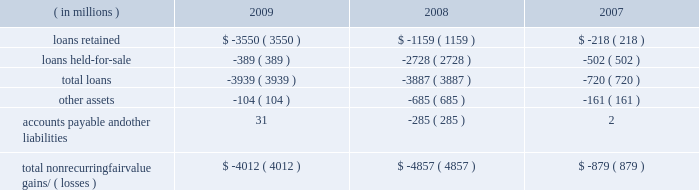Notes to consolidated financial statements jpmorgan chase & co./2009 annual report 168 nonrecurring fair value changes the table presents the total change in value of financial instruments for which a fair value adjustment has been included in the consolidated statements of income for the years ended december 31 , 2009 , 2008 and 2007 , related to financial instru- ments held at these dates .
Year ended december 31 .
Accounts payable and other liabilities 31 ( 285 ) 2 total nonrecurring fair value gains/ ( losses ) $ ( 4012 ) $ ( 4857 ) $ ( 879 ) in the above table , loans predominantly include : ( 1 ) write-downs of delinquent mortgage and home equity loans where impairment is based on the fair value of the underlying collateral ; and ( 2 ) the change in fair value for leveraged lending loans carried on the consolidated balance sheets at the lower of cost or fair value .
Accounts payable and other liabilities predominantly include the change in fair value for unfunded lending-related commitments within the leveraged lending portfolio .
Level 3 analysis level 3 assets ( including assets measured at fair value on a nonre- curring basis ) were 6% ( 6 % ) of total firm assets at both december 31 , 2009 and 2008 .
Level 3 assets were $ 130.4 billion at december 31 , 2009 , reflecting a decrease of $ 7.3 billion in 2009 , due to the following : 2022 a net decrease of $ 6.3 billion in gross derivative receivables , predominantly driven by the tightening of credit spreads .
Offset- ting a portion of the decrease were net transfers into level 3 dur- ing the year , most notably a transfer into level 3 of $ 41.3 billion of structured credit derivative receivables , and a transfer out of level 3 of $ 17.7 billion of single-name cds on abs .
The fair value of the receivables transferred into level 3 during the year was $ 22.1 billion at december 31 , 2009 .
The fair value of struc- tured credit derivative payables with a similar underlying risk profile to the previously noted receivables , that are also classified in level 3 , was $ 12.5 billion at december 31 , 2009 .
These de- rivatives payables offset the receivables , as they are modeled and valued the same way with the same parameters and inputs as the assets .
2022 a net decrease of $ 3.5 billion in loans , predominantly driven by sales of leveraged loans and transfers of similar loans to level 2 , due to increased price transparency for such assets .
Leveraged loans are typically classified as held-for-sale and measured at the lower of cost or fair value and , therefore , included in the nonre- curring fair value assets .
2022 a net decrease of $ 6.3 billion in trading assets 2013 debt and equity instruments , primarily in loans and residential- and commercial- mbs , principally driven by sales and markdowns , and by sales and unwinds of structured transactions with hedge funds .
The declines were partially offset by a transfer from level 2 to level 3 of certain structured notes reflecting lower liquidity and less pricing ob- servability , and also increases in the fair value of other abs .
2022 a net increase of $ 6.1 billion in msrs , due to increases in the fair value of the asset , related primarily to market interest rate and other changes affecting the firm's estimate of future pre- payments , as well as sales in rfs of originated loans for which servicing rights were retained .
These increases were offset par- tially by servicing portfolio runoff .
2022 a net increase of $ 1.9 billion in accrued interest and accounts receivable related to increases in subordinated retained interests from the firm 2019s credit card securitization activities .
Gains and losses gains and losses included in the tables for 2009 and 2008 included : 2022 $ 11.4 billion of net losses on derivatives , primarily related to the tightening of credit spreads .
2022 net losses on trading 2013debt and equity instruments of $ 671 million , consisting of $ 2.1 billion of losses , primarily related to residential and commercial loans and mbs , principally driven by markdowns and sales , partially offset by gains of $ 1.4 billion , reflecting increases in the fair value of other abs .
( for a further discussion of the gains and losses on mortgage-related expo- sures , inclusive of risk management activities , see the 201cmort- gage-related exposures carried at fair value 201d discussion below. ) 2022 $ 5.8 billion of gains on msrs .
2022 $ 1.4 billion of losses related to structured note liabilities , pre- dominantly due to volatility in the equity markets .
2022 losses on trading-debt and equity instruments of approximately $ 12.8 billion , principally from mortgage-related transactions and auction-rate securities .
2022 losses of $ 6.9 billion on msrs .
2022 losses of approximately $ 3.9 billion on leveraged loans .
2022 net gains of $ 4.6 billion related to derivatives , principally due to changes in credit spreads and rate curves .
2022 gains of $ 4.5 billion related to structured notes , principally due to significant volatility in the fixed income , commodities and eq- uity markets .
2022 private equity losses of $ 638 million .
For further information on changes in the fair value of the msrs , see note 17 on pages 223 2013224 of this annual report. .
Considering the year 2008 , what is the percentage of loans held-for-sale in total loans? 
Rationale: it is the loans held-for-sale divided by the total loans in 2008 .
Computations: (2728 / 3887)
Answer: 0.70183. Notes to consolidated financial statements jpmorgan chase & co./2009 annual report 168 nonrecurring fair value changes the table presents the total change in value of financial instruments for which a fair value adjustment has been included in the consolidated statements of income for the years ended december 31 , 2009 , 2008 and 2007 , related to financial instru- ments held at these dates .
Year ended december 31 .
Accounts payable and other liabilities 31 ( 285 ) 2 total nonrecurring fair value gains/ ( losses ) $ ( 4012 ) $ ( 4857 ) $ ( 879 ) in the above table , loans predominantly include : ( 1 ) write-downs of delinquent mortgage and home equity loans where impairment is based on the fair value of the underlying collateral ; and ( 2 ) the change in fair value for leveraged lending loans carried on the consolidated balance sheets at the lower of cost or fair value .
Accounts payable and other liabilities predominantly include the change in fair value for unfunded lending-related commitments within the leveraged lending portfolio .
Level 3 analysis level 3 assets ( including assets measured at fair value on a nonre- curring basis ) were 6% ( 6 % ) of total firm assets at both december 31 , 2009 and 2008 .
Level 3 assets were $ 130.4 billion at december 31 , 2009 , reflecting a decrease of $ 7.3 billion in 2009 , due to the following : 2022 a net decrease of $ 6.3 billion in gross derivative receivables , predominantly driven by the tightening of credit spreads .
Offset- ting a portion of the decrease were net transfers into level 3 dur- ing the year , most notably a transfer into level 3 of $ 41.3 billion of structured credit derivative receivables , and a transfer out of level 3 of $ 17.7 billion of single-name cds on abs .
The fair value of the receivables transferred into level 3 during the year was $ 22.1 billion at december 31 , 2009 .
The fair value of struc- tured credit derivative payables with a similar underlying risk profile to the previously noted receivables , that are also classified in level 3 , was $ 12.5 billion at december 31 , 2009 .
These de- rivatives payables offset the receivables , as they are modeled and valued the same way with the same parameters and inputs as the assets .
2022 a net decrease of $ 3.5 billion in loans , predominantly driven by sales of leveraged loans and transfers of similar loans to level 2 , due to increased price transparency for such assets .
Leveraged loans are typically classified as held-for-sale and measured at the lower of cost or fair value and , therefore , included in the nonre- curring fair value assets .
2022 a net decrease of $ 6.3 billion in trading assets 2013 debt and equity instruments , primarily in loans and residential- and commercial- mbs , principally driven by sales and markdowns , and by sales and unwinds of structured transactions with hedge funds .
The declines were partially offset by a transfer from level 2 to level 3 of certain structured notes reflecting lower liquidity and less pricing ob- servability , and also increases in the fair value of other abs .
2022 a net increase of $ 6.1 billion in msrs , due to increases in the fair value of the asset , related primarily to market interest rate and other changes affecting the firm's estimate of future pre- payments , as well as sales in rfs of originated loans for which servicing rights were retained .
These increases were offset par- tially by servicing portfolio runoff .
2022 a net increase of $ 1.9 billion in accrued interest and accounts receivable related to increases in subordinated retained interests from the firm 2019s credit card securitization activities .
Gains and losses gains and losses included in the tables for 2009 and 2008 included : 2022 $ 11.4 billion of net losses on derivatives , primarily related to the tightening of credit spreads .
2022 net losses on trading 2013debt and equity instruments of $ 671 million , consisting of $ 2.1 billion of losses , primarily related to residential and commercial loans and mbs , principally driven by markdowns and sales , partially offset by gains of $ 1.4 billion , reflecting increases in the fair value of other abs .
( for a further discussion of the gains and losses on mortgage-related expo- sures , inclusive of risk management activities , see the 201cmort- gage-related exposures carried at fair value 201d discussion below. ) 2022 $ 5.8 billion of gains on msrs .
2022 $ 1.4 billion of losses related to structured note liabilities , pre- dominantly due to volatility in the equity markets .
2022 losses on trading-debt and equity instruments of approximately $ 12.8 billion , principally from mortgage-related transactions and auction-rate securities .
2022 losses of $ 6.9 billion on msrs .
2022 losses of approximately $ 3.9 billion on leveraged loans .
2022 net gains of $ 4.6 billion related to derivatives , principally due to changes in credit spreads and rate curves .
2022 gains of $ 4.5 billion related to structured notes , principally due to significant volatility in the fixed income , commodities and eq- uity markets .
2022 private equity losses of $ 638 million .
For further information on changes in the fair value of the msrs , see note 17 on pages 223 2013224 of this annual report. .
What was the percent of the total loans as part the total nonrecurring fair value gains/ ( losses )? 
Computations: (3939 / 4012)
Answer: 0.9818. 